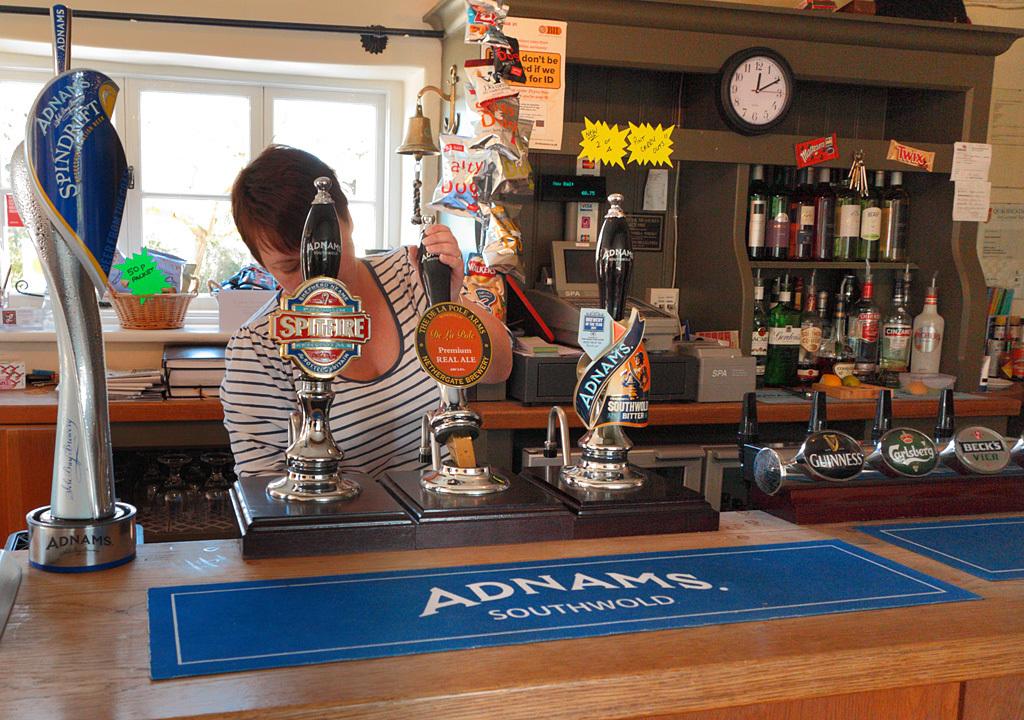What is written below adnams?
Your answer should be very brief. Southwold. What time can we see on the clock?
Your answer should be compact. 12:10. 